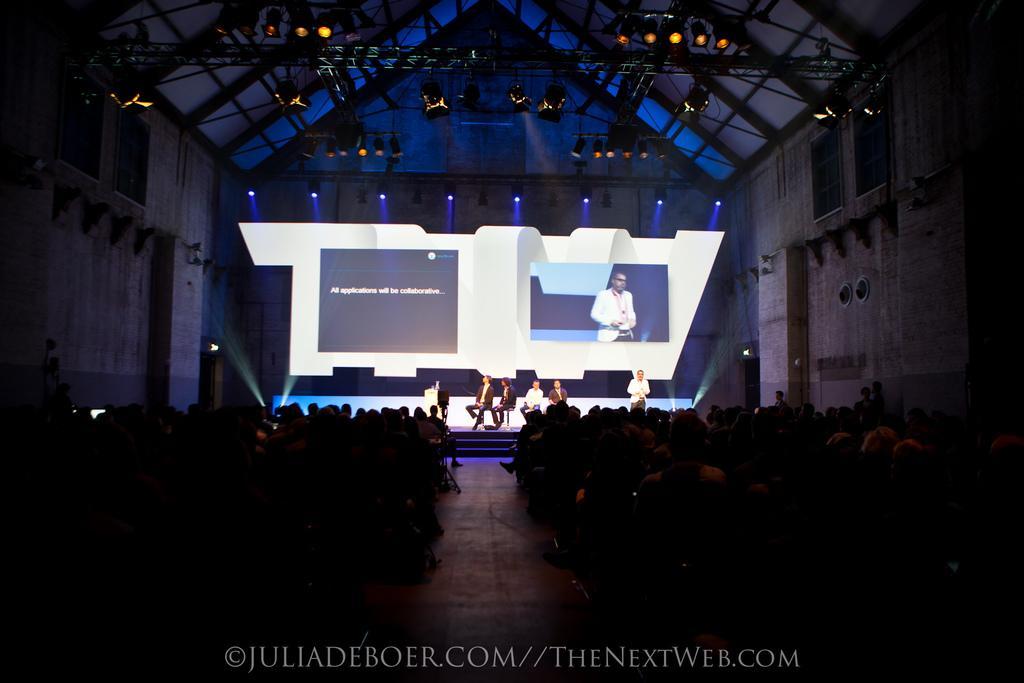How would you summarize this image in a sentence or two? In this image we can see a few people, among them some people are on the stage, in the background we can see a projector with some text and image, there are some focus lights, metal rods and the wall. 